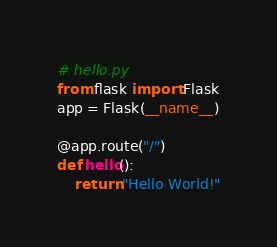Convert code to text. <code><loc_0><loc_0><loc_500><loc_500><_Python_># hello.py
from flask import Flask
app = Flask(__name__)

@app.route("/")
def hello():
    return "Hello World!"</code> 